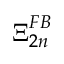Convert formula to latex. <formula><loc_0><loc_0><loc_500><loc_500>\Xi _ { 2 n } ^ { F B }</formula> 